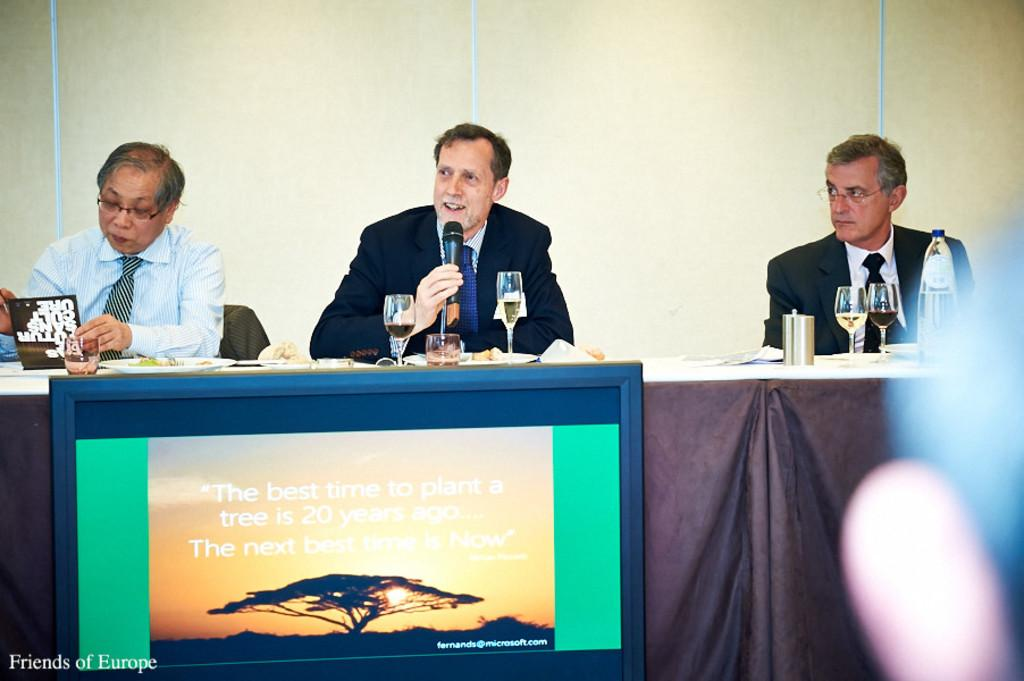<image>
Render a clear and concise summary of the photo. A sign telling people that the best time to plant a tree was 20 years ago 